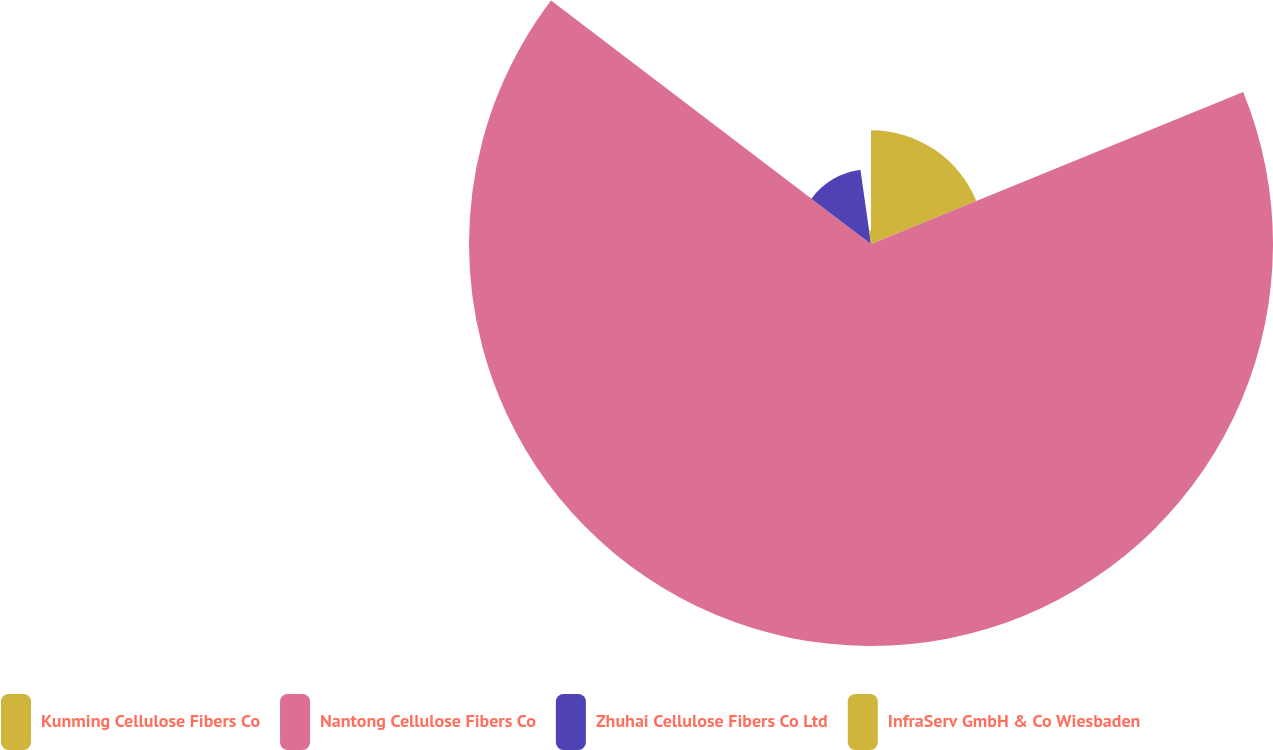<chart> <loc_0><loc_0><loc_500><loc_500><pie_chart><fcel>Kunming Cellulose Fibers Co<fcel>Nantong Cellulose Fibers Co<fcel>Zhuhai Cellulose Fibers Co Ltd<fcel>InfraServ GmbH & Co Wiesbaden<nl><fcel>18.83%<fcel>66.52%<fcel>12.4%<fcel>2.25%<nl></chart> 